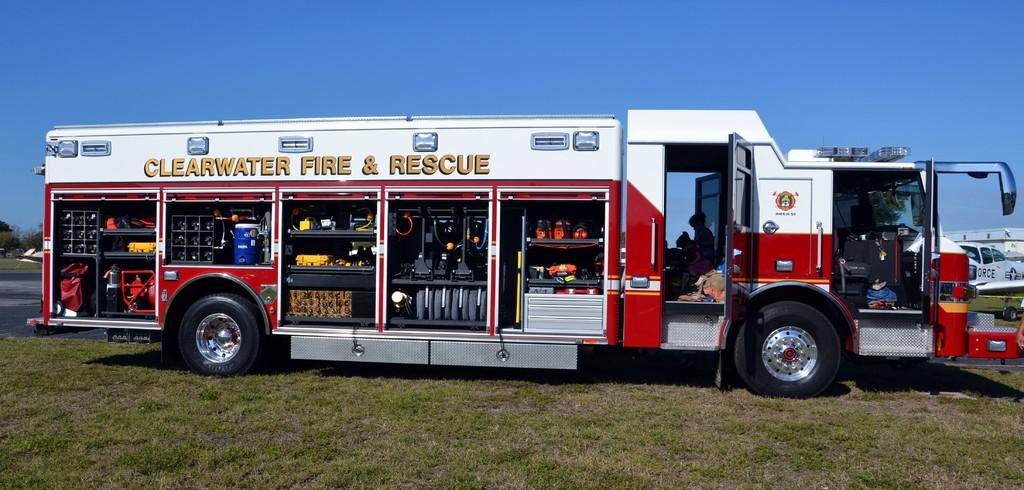What is the main subject of the image? There is a fire rescue truck in the image. What type of terrain is visible at the bottom of the image? There is grass at the bottom of the image. What is visible at the top of the image? There is sky visible at the top of the image. What can be seen on the left side of the image? There is a road on the left side of the image. Can you tell me the condition of the rabbit in the image? There is no rabbit present in the image, so it is not possible to determine its condition. 